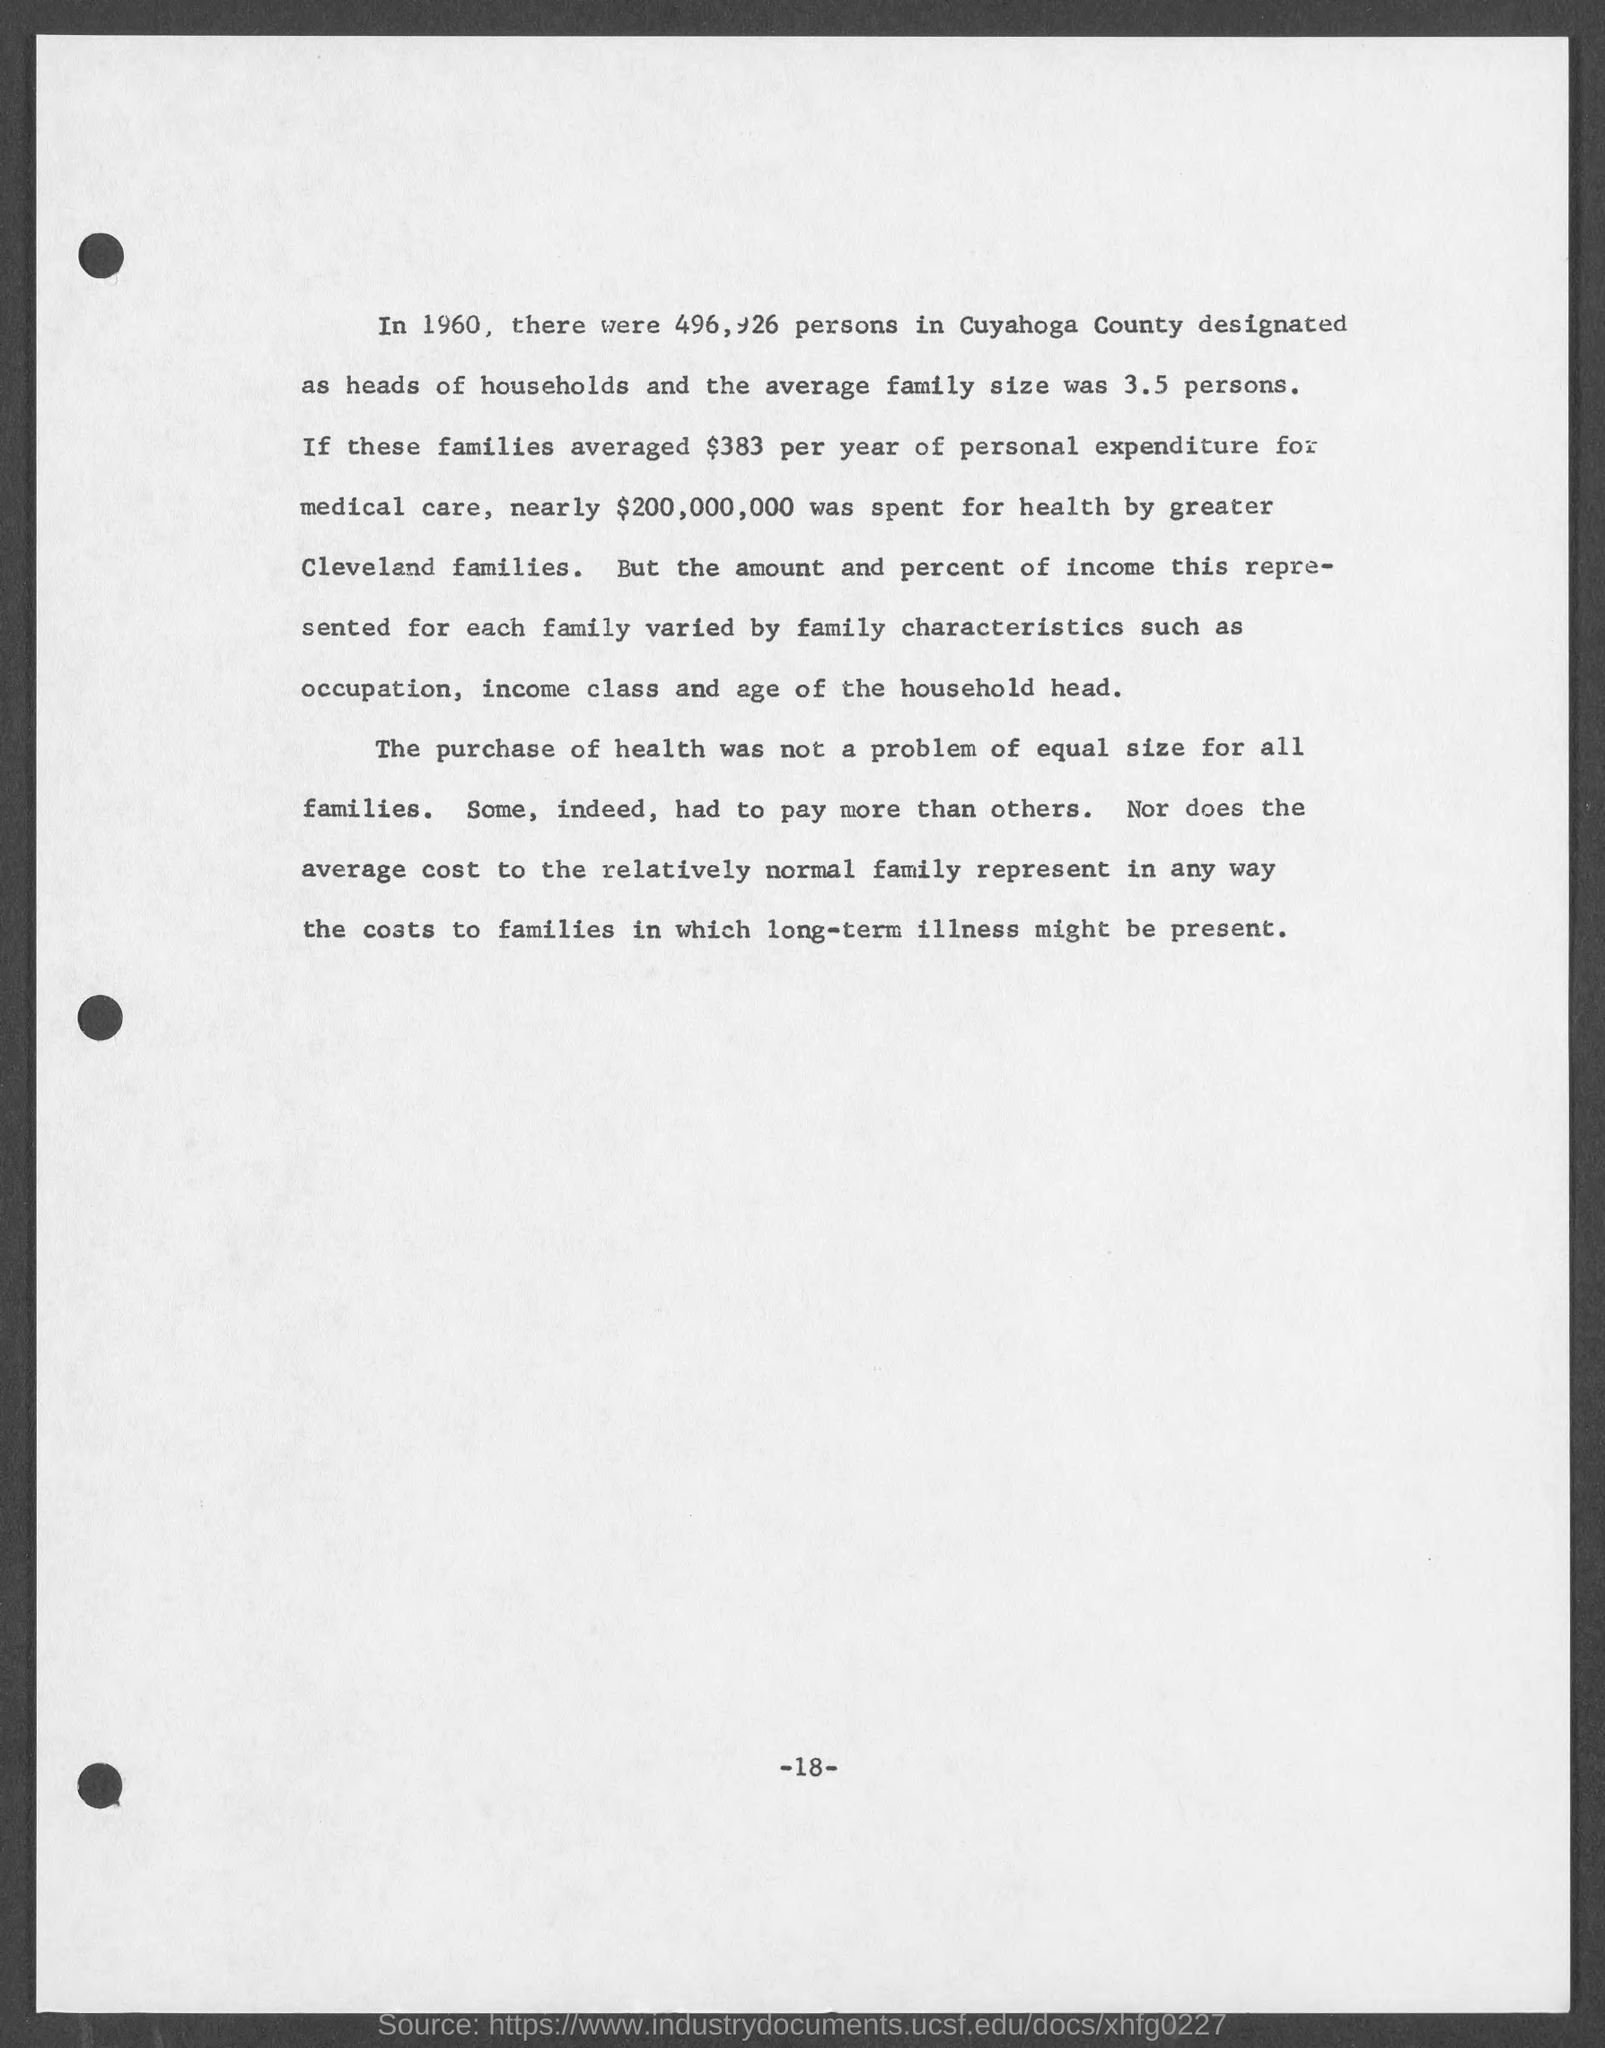Identify some key points in this picture. The number at the bottom of the page is 18. 